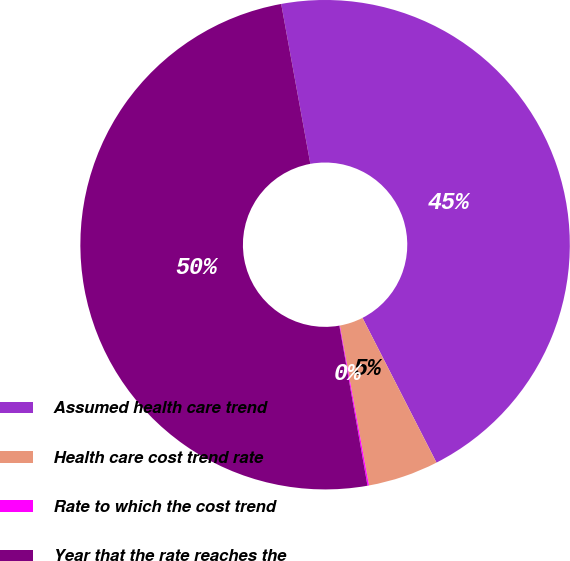<chart> <loc_0><loc_0><loc_500><loc_500><pie_chart><fcel>Assumed health care trend<fcel>Health care cost trend rate<fcel>Rate to which the cost trend<fcel>Year that the rate reaches the<nl><fcel>45.35%<fcel>4.65%<fcel>0.1%<fcel>49.9%<nl></chart> 